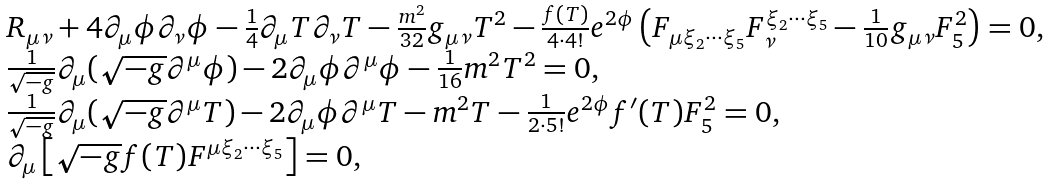Convert formula to latex. <formula><loc_0><loc_0><loc_500><loc_500>\begin{array} { l } R _ { \mu \nu } + 4 \partial _ { \mu } \phi \partial _ { \nu } \phi - \frac { 1 } { 4 } \partial _ { \mu } T \partial _ { \nu } T - \frac { m ^ { 2 } } { 3 2 } g _ { \mu \nu } T ^ { 2 } - \frac { f ( T ) } { 4 \cdot 4 ! } e ^ { 2 \phi } \left ( F _ { \mu \xi _ { 2 } \cdots \xi _ { 5 } } F _ { \nu } ^ { \xi _ { 2 } \cdots \xi _ { 5 } } - \frac { 1 } { 1 0 } g _ { \mu \nu } F ^ { 2 } _ { 5 } \right ) = 0 , \\ \frac { 1 } { \sqrt { - g } } \partial _ { \mu } ( \sqrt { - g } \partial ^ { \mu } \phi ) - 2 \partial _ { \mu } \phi \partial ^ { \mu } \phi - \frac { 1 } { 1 6 } m ^ { 2 } T ^ { 2 } = 0 , \\ \frac { 1 } { \sqrt { - g } } \partial _ { \mu } ( \sqrt { - g } \partial ^ { \mu } T ) - 2 \partial _ { \mu } \phi \partial ^ { \mu } T - m ^ { 2 } T - \frac { 1 } { 2 \cdot 5 ! } e ^ { 2 \phi } f ^ { \prime } ( T ) F ^ { 2 } _ { 5 } = 0 , \\ \partial _ { \mu } \left [ \sqrt { - g } f ( T ) F ^ { \mu \xi _ { 2 } \cdots \xi _ { 5 } } \right ] = 0 , \end{array}</formula> 